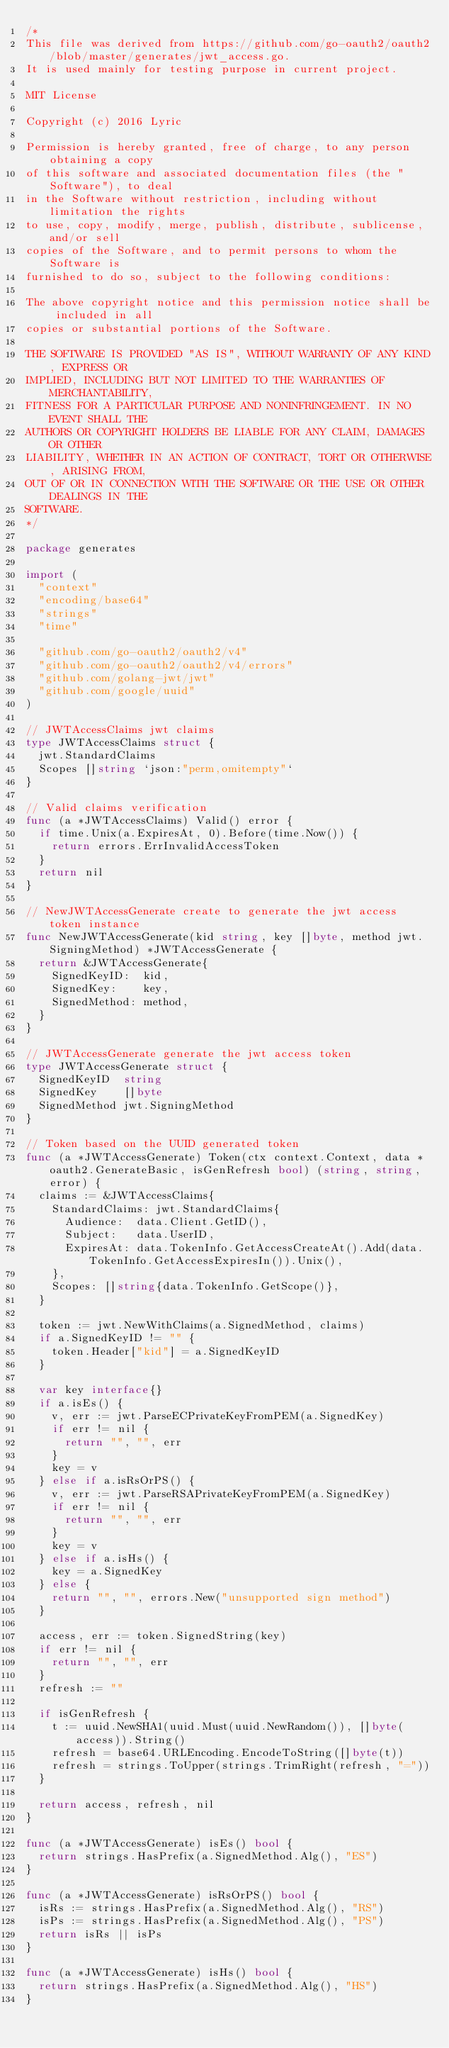Convert code to text. <code><loc_0><loc_0><loc_500><loc_500><_Go_>/*
This file was derived from https://github.com/go-oauth2/oauth2/blob/master/generates/jwt_access.go.
It is used mainly for testing purpose in current project.

MIT License

Copyright (c) 2016 Lyric

Permission is hereby granted, free of charge, to any person obtaining a copy
of this software and associated documentation files (the "Software"), to deal
in the Software without restriction, including without limitation the rights
to use, copy, modify, merge, publish, distribute, sublicense, and/or sell
copies of the Software, and to permit persons to whom the Software is
furnished to do so, subject to the following conditions:

The above copyright notice and this permission notice shall be included in all
copies or substantial portions of the Software.

THE SOFTWARE IS PROVIDED "AS IS", WITHOUT WARRANTY OF ANY KIND, EXPRESS OR
IMPLIED, INCLUDING BUT NOT LIMITED TO THE WARRANTIES OF MERCHANTABILITY,
FITNESS FOR A PARTICULAR PURPOSE AND NONINFRINGEMENT. IN NO EVENT SHALL THE
AUTHORS OR COPYRIGHT HOLDERS BE LIABLE FOR ANY CLAIM, DAMAGES OR OTHER
LIABILITY, WHETHER IN AN ACTION OF CONTRACT, TORT OR OTHERWISE, ARISING FROM,
OUT OF OR IN CONNECTION WITH THE SOFTWARE OR THE USE OR OTHER DEALINGS IN THE
SOFTWARE.
*/

package generates

import (
	"context"
	"encoding/base64"
	"strings"
	"time"

	"github.com/go-oauth2/oauth2/v4"
	"github.com/go-oauth2/oauth2/v4/errors"
	"github.com/golang-jwt/jwt"
	"github.com/google/uuid"
)

// JWTAccessClaims jwt claims
type JWTAccessClaims struct {
	jwt.StandardClaims
	Scopes []string `json:"perm,omitempty"`
}

// Valid claims verification
func (a *JWTAccessClaims) Valid() error {
	if time.Unix(a.ExpiresAt, 0).Before(time.Now()) {
		return errors.ErrInvalidAccessToken
	}
	return nil
}

// NewJWTAccessGenerate create to generate the jwt access token instance
func NewJWTAccessGenerate(kid string, key []byte, method jwt.SigningMethod) *JWTAccessGenerate {
	return &JWTAccessGenerate{
		SignedKeyID:  kid,
		SignedKey:    key,
		SignedMethod: method,
	}
}

// JWTAccessGenerate generate the jwt access token
type JWTAccessGenerate struct {
	SignedKeyID  string
	SignedKey    []byte
	SignedMethod jwt.SigningMethod
}

// Token based on the UUID generated token
func (a *JWTAccessGenerate) Token(ctx context.Context, data *oauth2.GenerateBasic, isGenRefresh bool) (string, string, error) {
	claims := &JWTAccessClaims{
		StandardClaims: jwt.StandardClaims{
			Audience:  data.Client.GetID(),
			Subject:   data.UserID,
			ExpiresAt: data.TokenInfo.GetAccessCreateAt().Add(data.TokenInfo.GetAccessExpiresIn()).Unix(),
		},
		Scopes: []string{data.TokenInfo.GetScope()},
	}

	token := jwt.NewWithClaims(a.SignedMethod, claims)
	if a.SignedKeyID != "" {
		token.Header["kid"] = a.SignedKeyID
	}

	var key interface{}
	if a.isEs() {
		v, err := jwt.ParseECPrivateKeyFromPEM(a.SignedKey)
		if err != nil {
			return "", "", err
		}
		key = v
	} else if a.isRsOrPS() {
		v, err := jwt.ParseRSAPrivateKeyFromPEM(a.SignedKey)
		if err != nil {
			return "", "", err
		}
		key = v
	} else if a.isHs() {
		key = a.SignedKey
	} else {
		return "", "", errors.New("unsupported sign method")
	}

	access, err := token.SignedString(key)
	if err != nil {
		return "", "", err
	}
	refresh := ""

	if isGenRefresh {
		t := uuid.NewSHA1(uuid.Must(uuid.NewRandom()), []byte(access)).String()
		refresh = base64.URLEncoding.EncodeToString([]byte(t))
		refresh = strings.ToUpper(strings.TrimRight(refresh, "="))
	}

	return access, refresh, nil
}

func (a *JWTAccessGenerate) isEs() bool {
	return strings.HasPrefix(a.SignedMethod.Alg(), "ES")
}

func (a *JWTAccessGenerate) isRsOrPS() bool {
	isRs := strings.HasPrefix(a.SignedMethod.Alg(), "RS")
	isPs := strings.HasPrefix(a.SignedMethod.Alg(), "PS")
	return isRs || isPs
}

func (a *JWTAccessGenerate) isHs() bool {
	return strings.HasPrefix(a.SignedMethod.Alg(), "HS")
}
</code> 